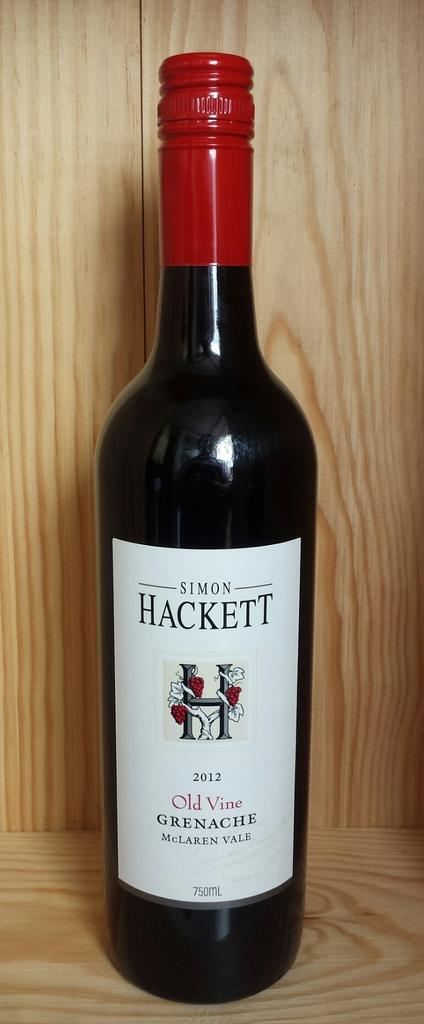Provide a one-sentence caption for the provided image. A bottle of Simon Hackett wine from 2012. 